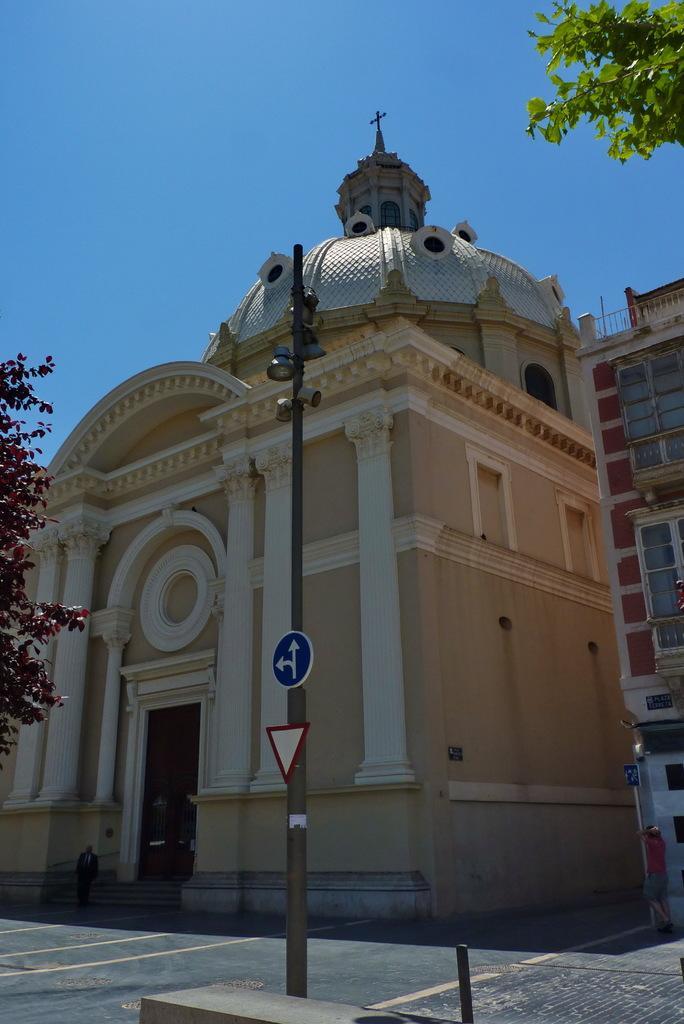How would you summarize this image in a sentence or two? In this image there are boards and lights attached to the pole, trees, buildings, and in the background there is sky. 